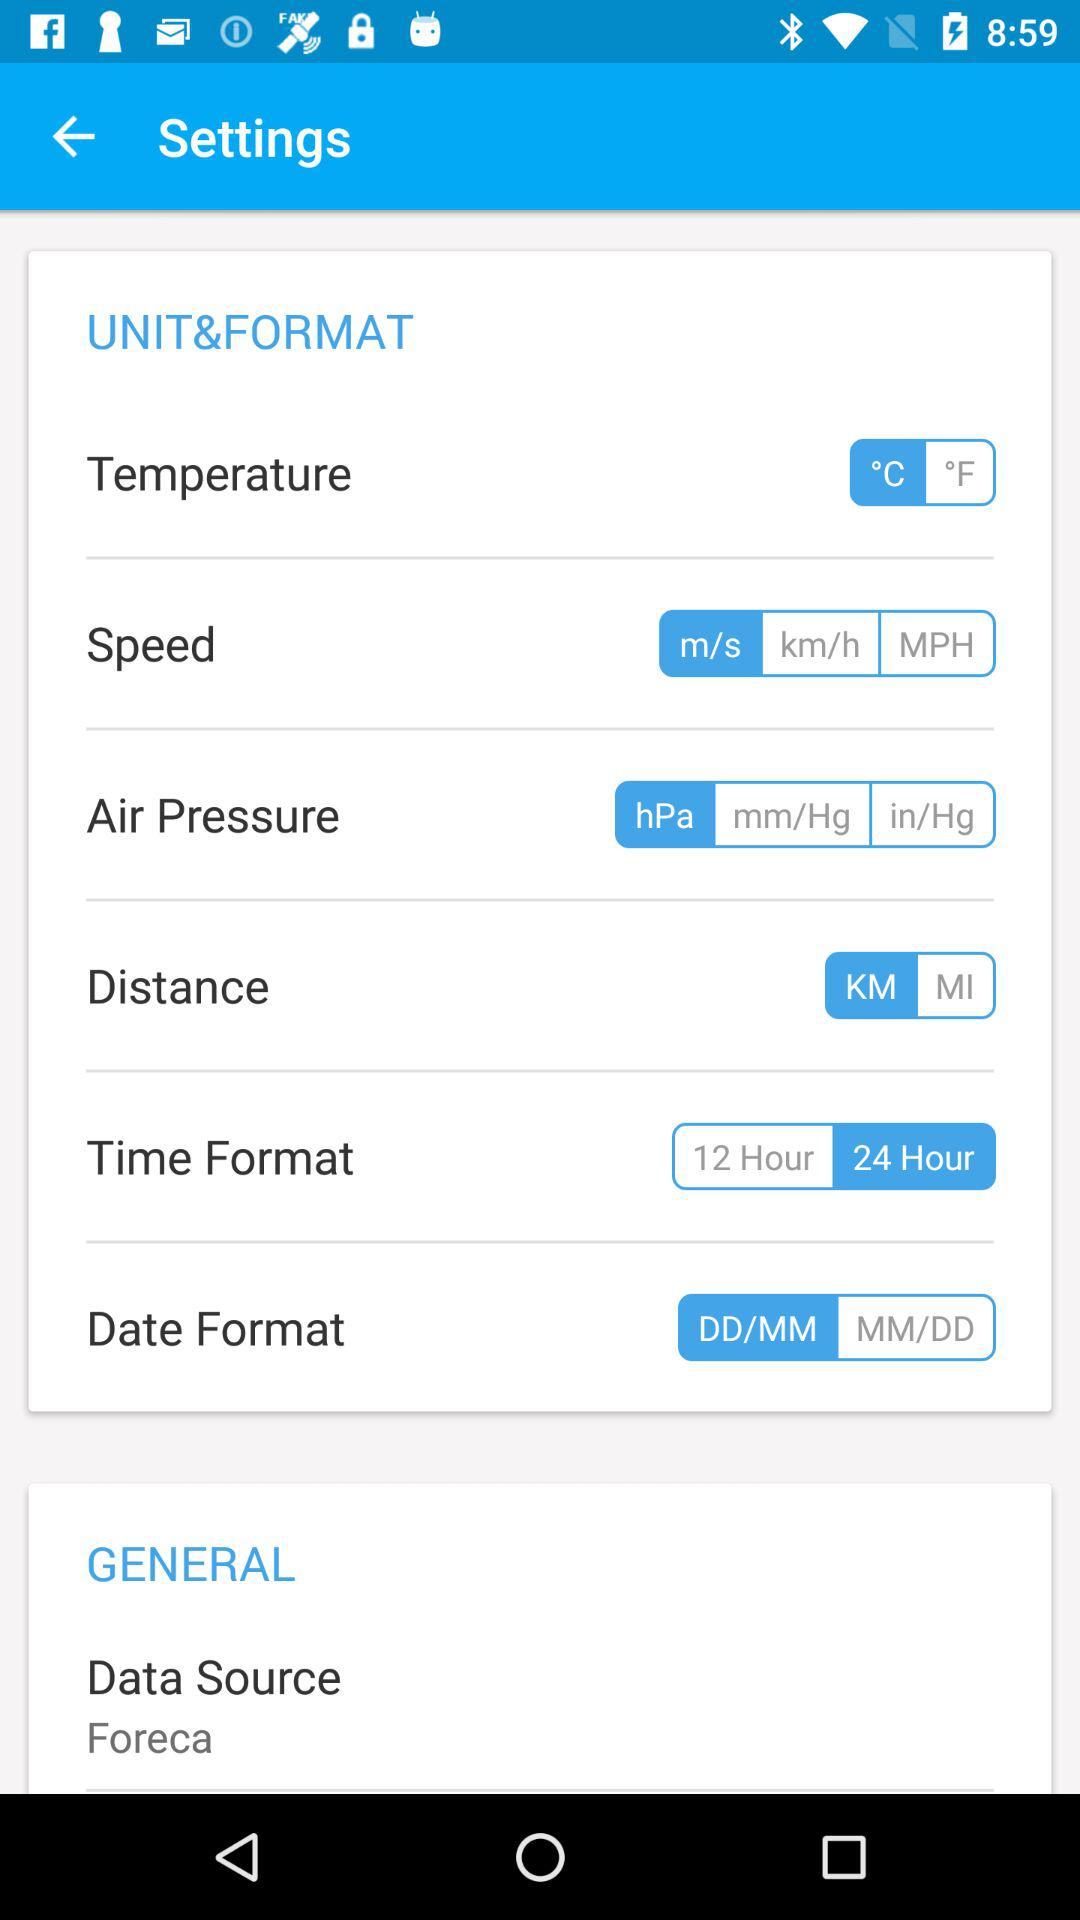What is the distance measurement unit? The distance measurement unit is the kilometer. 